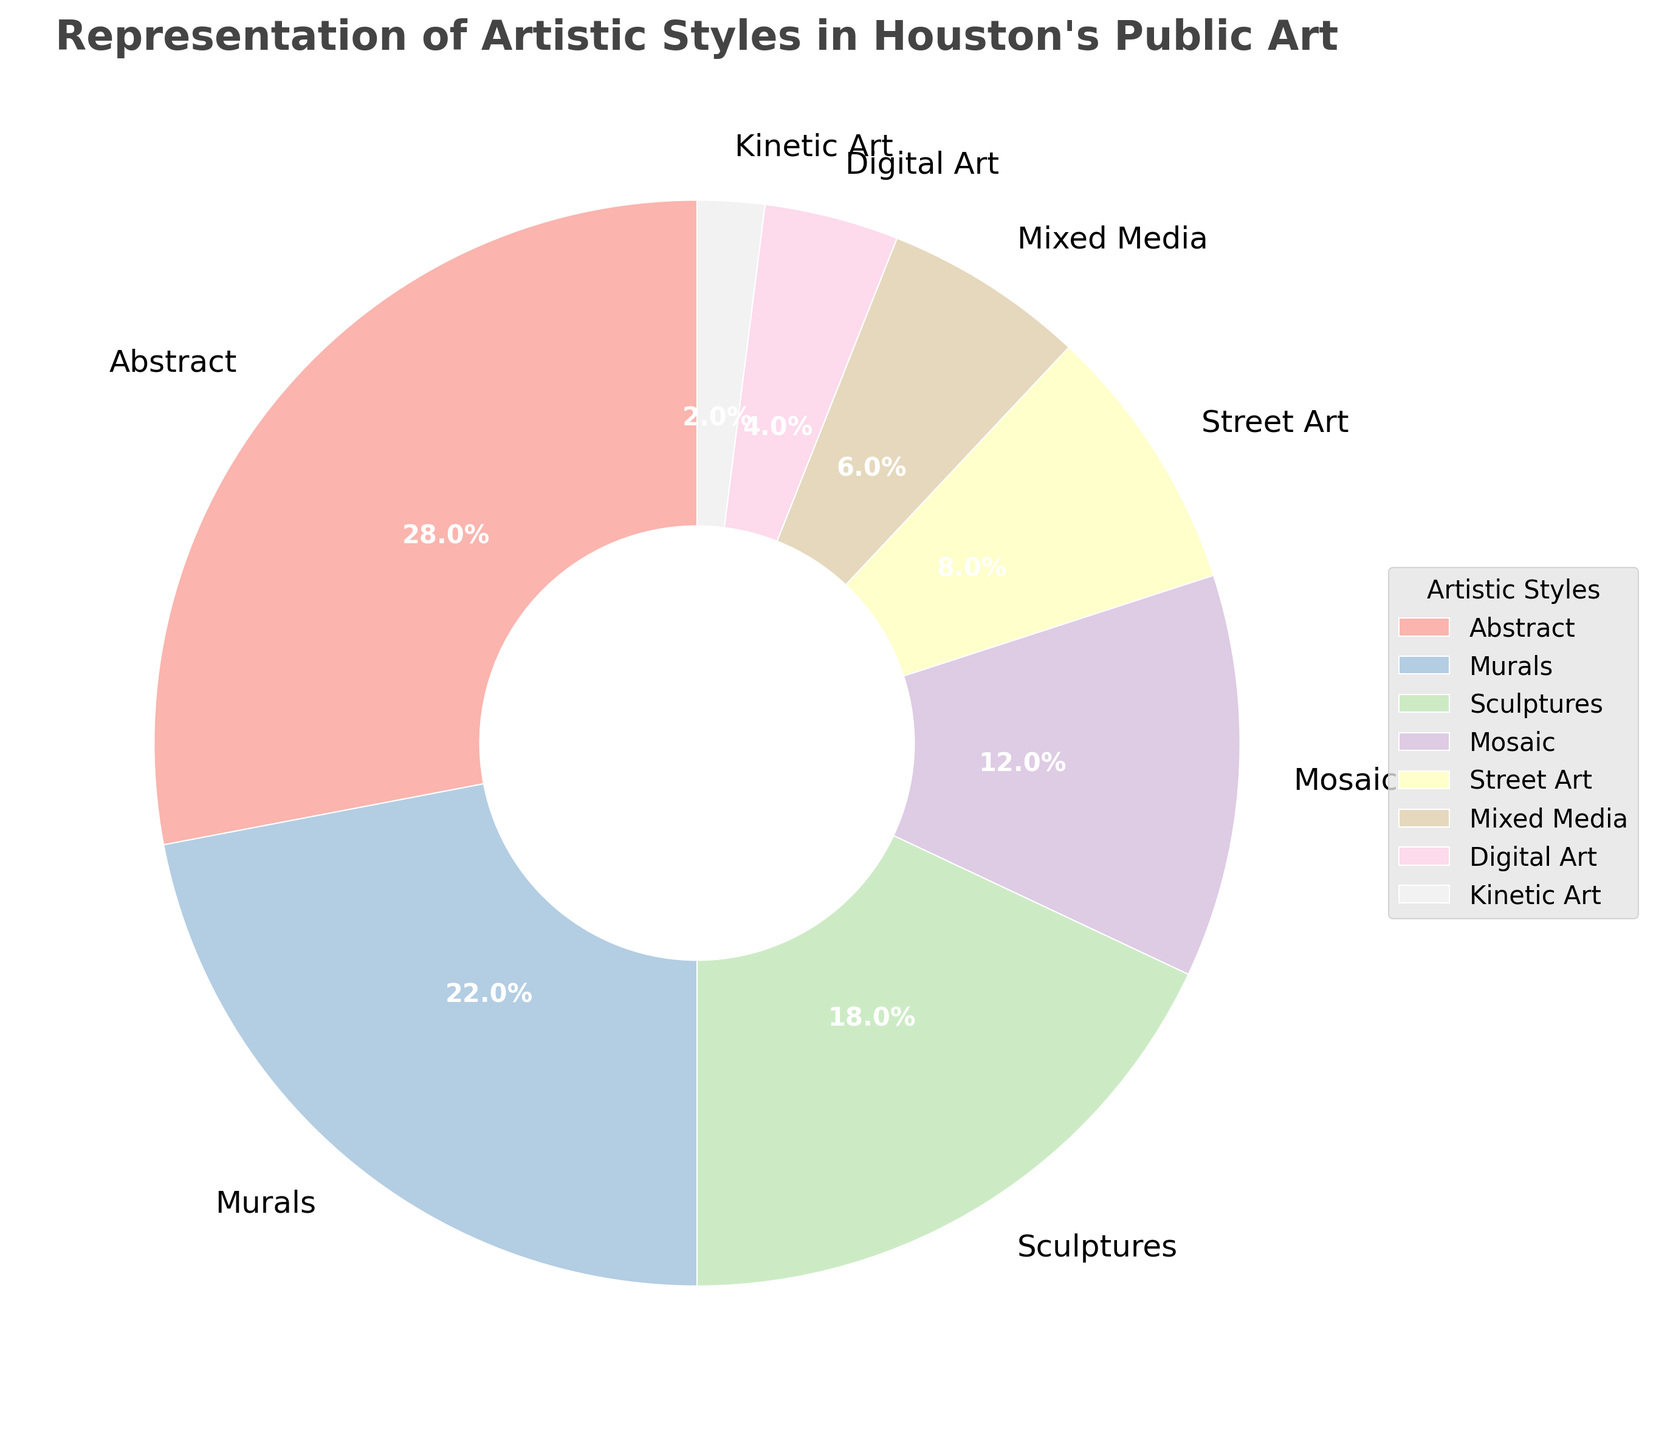What artistic style constitutes the largest portion of Houston’s public art installations? The largest portion of the pie chart is labeled "Abstract" with a percentage of 28%. Hence, Abstract is the largest portion.
Answer: Abstract Which two artistic styles have the closest representation percentages, and what are those percentages? To find the closest percentages, compare the percentages of all the styles. Murals (22%) and Sculptures (18%) have the closest representation percentages.
Answer: Murals (22%) and Sculptures (18%) What is the combined percentage of Street Art, Mixed Media, Digital Art, and Kinetic Art? The combined percentage is the sum of Street Art (8%), Mixed Media (6%), Digital Art (4%), and Kinetic Art (2%). So, 8 + 6 + 4 + 2 = 20%.
Answer: 20% Which artistic style takes up exactly one-fifth of the total representation in the pie chart? To determine one-fifth of the total representation, calculate 100% / 5 = 20%. The artistic style with 20% representation is Murals.
Answer: Murals Which artistic style is represented by the darkest color wedge in the pie chart? Referring to the shades of the colors, the darkest color wedge represents "Kinetic Art" with 2%.
Answer: Kinetic Art How much more represented is Abstract compared to Digital Art in Houston’s public art installations? The difference in representation is Abstract (28%) minus Digital Art (4%). So, 28% - 4% = 24%.
Answer: 24% How does the representation of Mixed Media compare to Abstract and Street Art when combined? The combined percentage of Abstract (28%) and Street Art (8%) is 28 + 8 = 36%. Mixed Media has 6%. Mixed Media is less represented than the combination of Abstract and Street Art.
Answer: Less What percentage does Mosaic represent and how does it rank among other styles in terms of representation size? Mosaic represents 12% of the total. It ranks 4th in representation size after Abstract (28%), Murals (22%), and Sculptures (18%).
Answer: 12%, 4th 